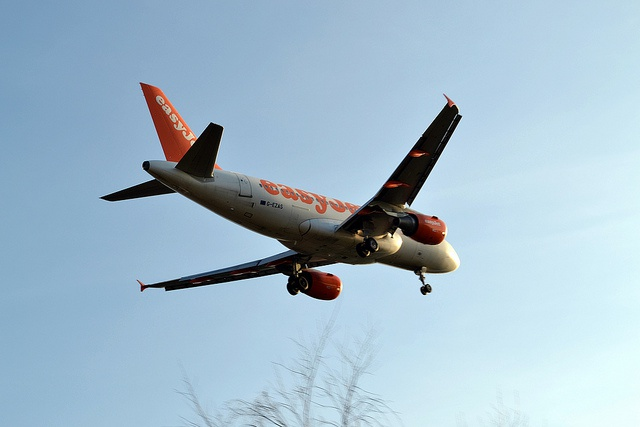Describe the objects in this image and their specific colors. I can see a airplane in darkgray, black, gray, and maroon tones in this image. 